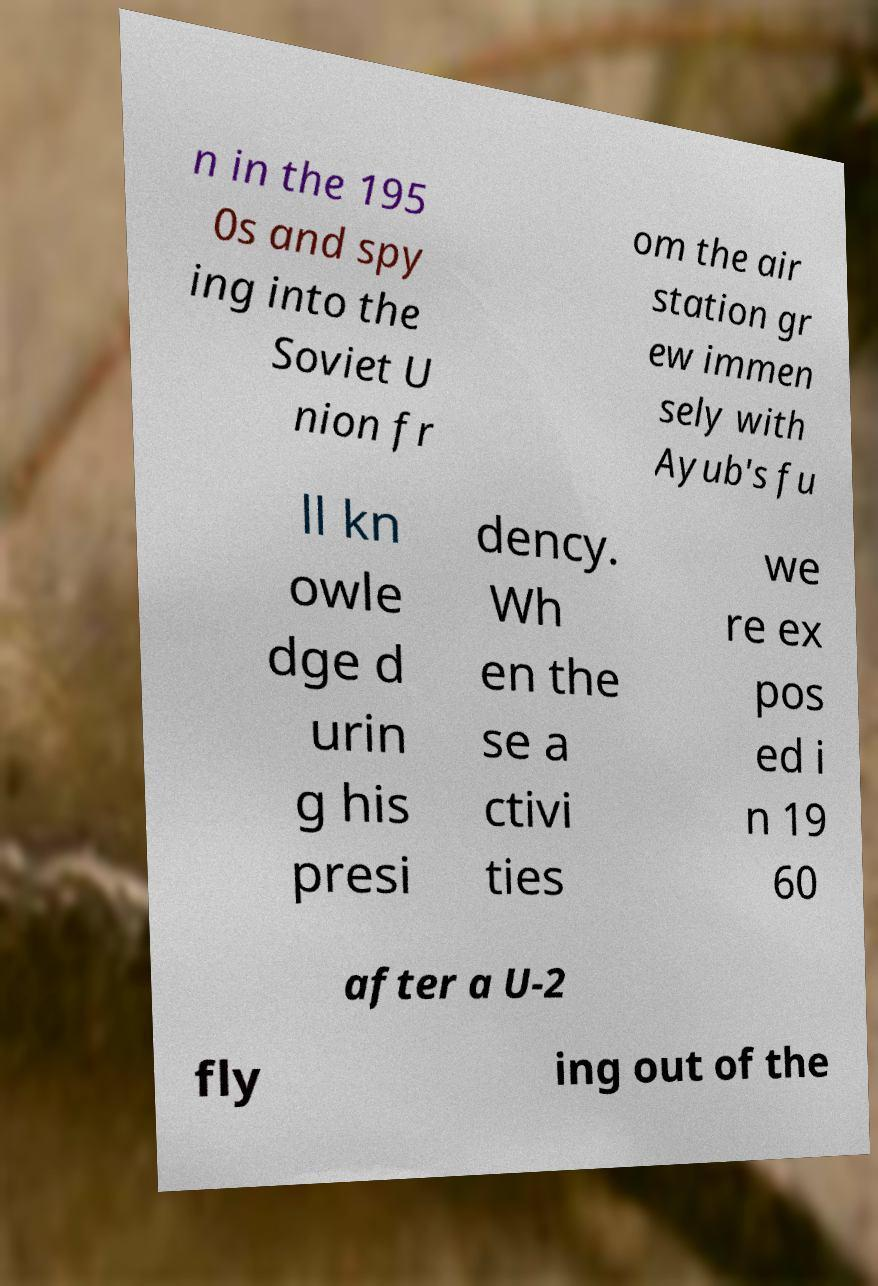Can you accurately transcribe the text from the provided image for me? n in the 195 0s and spy ing into the Soviet U nion fr om the air station gr ew immen sely with Ayub's fu ll kn owle dge d urin g his presi dency. Wh en the se a ctivi ties we re ex pos ed i n 19 60 after a U-2 fly ing out of the 